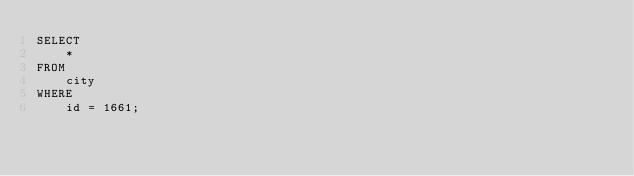<code> <loc_0><loc_0><loc_500><loc_500><_SQL_>SELECT
    *
FROM
    city
WHERE
    id = 1661;
</code> 